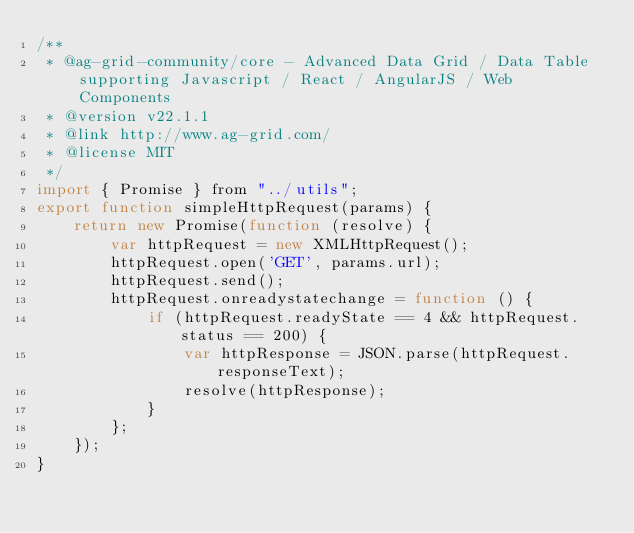Convert code to text. <code><loc_0><loc_0><loc_500><loc_500><_JavaScript_>/**
 * @ag-grid-community/core - Advanced Data Grid / Data Table supporting Javascript / React / AngularJS / Web Components
 * @version v22.1.1
 * @link http://www.ag-grid.com/
 * @license MIT
 */
import { Promise } from "../utils";
export function simpleHttpRequest(params) {
    return new Promise(function (resolve) {
        var httpRequest = new XMLHttpRequest();
        httpRequest.open('GET', params.url);
        httpRequest.send();
        httpRequest.onreadystatechange = function () {
            if (httpRequest.readyState == 4 && httpRequest.status == 200) {
                var httpResponse = JSON.parse(httpRequest.responseText);
                resolve(httpResponse);
            }
        };
    });
}
</code> 